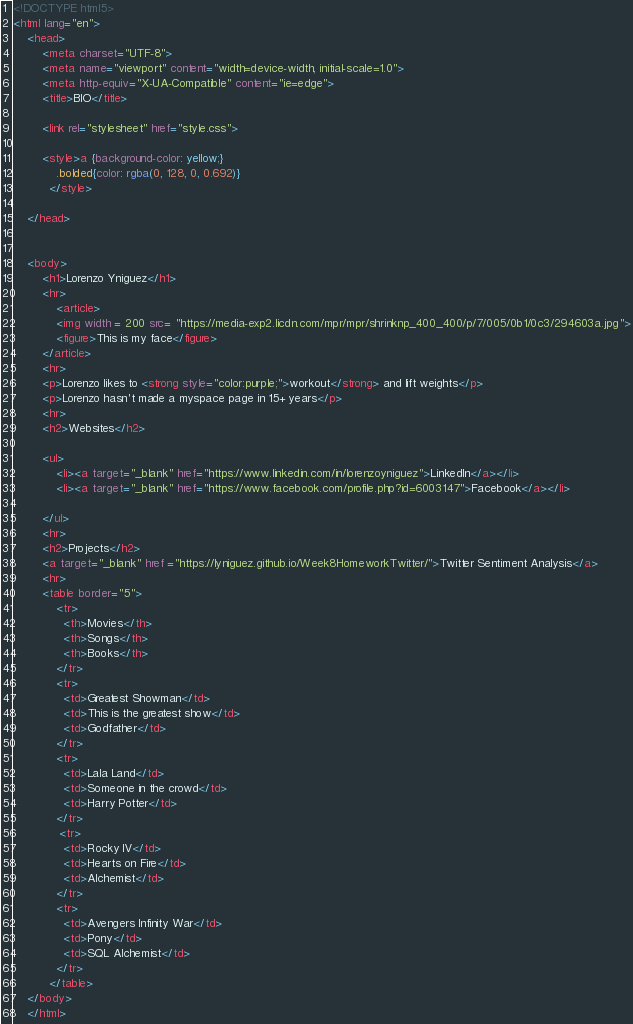Convert code to text. <code><loc_0><loc_0><loc_500><loc_500><_HTML_><!DOCTYPE html5>
<html lang="en">
    <head>
        <meta charset="UTF-8">
        <meta name="viewport" content="width=device-width, initial-scale=1.0">
        <meta http-equiv="X-UA-Compatible" content="ie=edge">
        <title>BIO</title>
    
        <link rel="stylesheet" href="style.css">
        
        <style>a {background-color: yellow;}
            .bolded{color: rgba(0, 128, 0, 0.692)}
          </style>
    
    </head>

   
    <body>
        <h1>Lorenzo Yniguez</h1>
        <hr>
            <article>
            <img width = 200 src= "https://media-exp2.licdn.com/mpr/mpr/shrinknp_400_400/p/7/005/0b1/0c3/294603a.jpg">
            <figure>This is my face</figure>
        </article>
        <hr>
        <p>Lorenzo likes to <strong style="color:purple;">workout</strong> and lift weights</p>
        <p>Lorenzo hasn't made a myspace page in 15+ years</p>
        <hr>
        <h2>Websites</h2>
        
        <ul>
            <li><a target="_blank" href="https://www.linkedin.com/in/lorenzoyniguez">LinkedIn</a></li>
            <li><a target="_blank" href="https://www.facebook.com/profile.php?id=6003147">Facebook</a></li>
         
        </ul>
        <hr>
        <h2>Projects</h2>
        <a target="_blank" href ="https://lyniguez.github.io/Week8HomeworkTwitter/">Twitter Sentiment Analysis</a>
        <hr>
        <table border="5"> 
            <tr> 
              <th>Movies</th> 
              <th>Songs</th> 
              <th>Books</th> 
            </tr> 
            <tr> 
              <td>Greatest Showman</td> 
              <td>This is the greatest show</td> 
              <td>Godfather</td> 
            </tr> 
            <tr> 
              <td>Lala Land</td> 
              <td>Someone in the crowd</td> 
              <td>Harry Potter</td> 
            </tr> 
             <tr> 
              <td>Rocky IV</td> 
              <td>Hearts on Fire</td> 
              <td>Alchemist</td> 
            </tr> 
            <tr> 
              <td>Avengers Infinity War</td> 
              <td>Pony</td> 
              <td>SQL Alchemist</td> 
            </tr> 
          </table>
    </body>
    </html></code> 